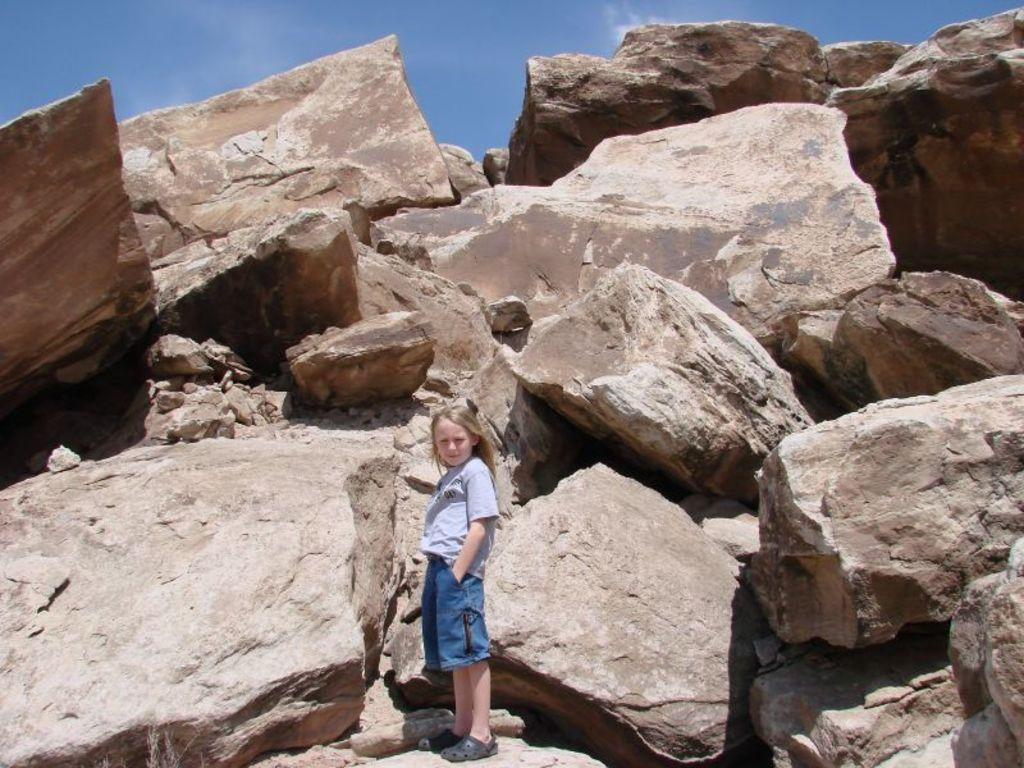Who is the main subject in the image? There is a girl standing in the center of the image. What other objects or features can be seen in the image? There is a group of rocks and stones in the image. What is visible in the background of the image? The sky is visible in the image. How would you describe the weather based on the sky in the image? The sky appears to be cloudy in the image. What type of winter sport is the girl participating in the image? There is no indication of a winter sport or any sports activity in the image. 